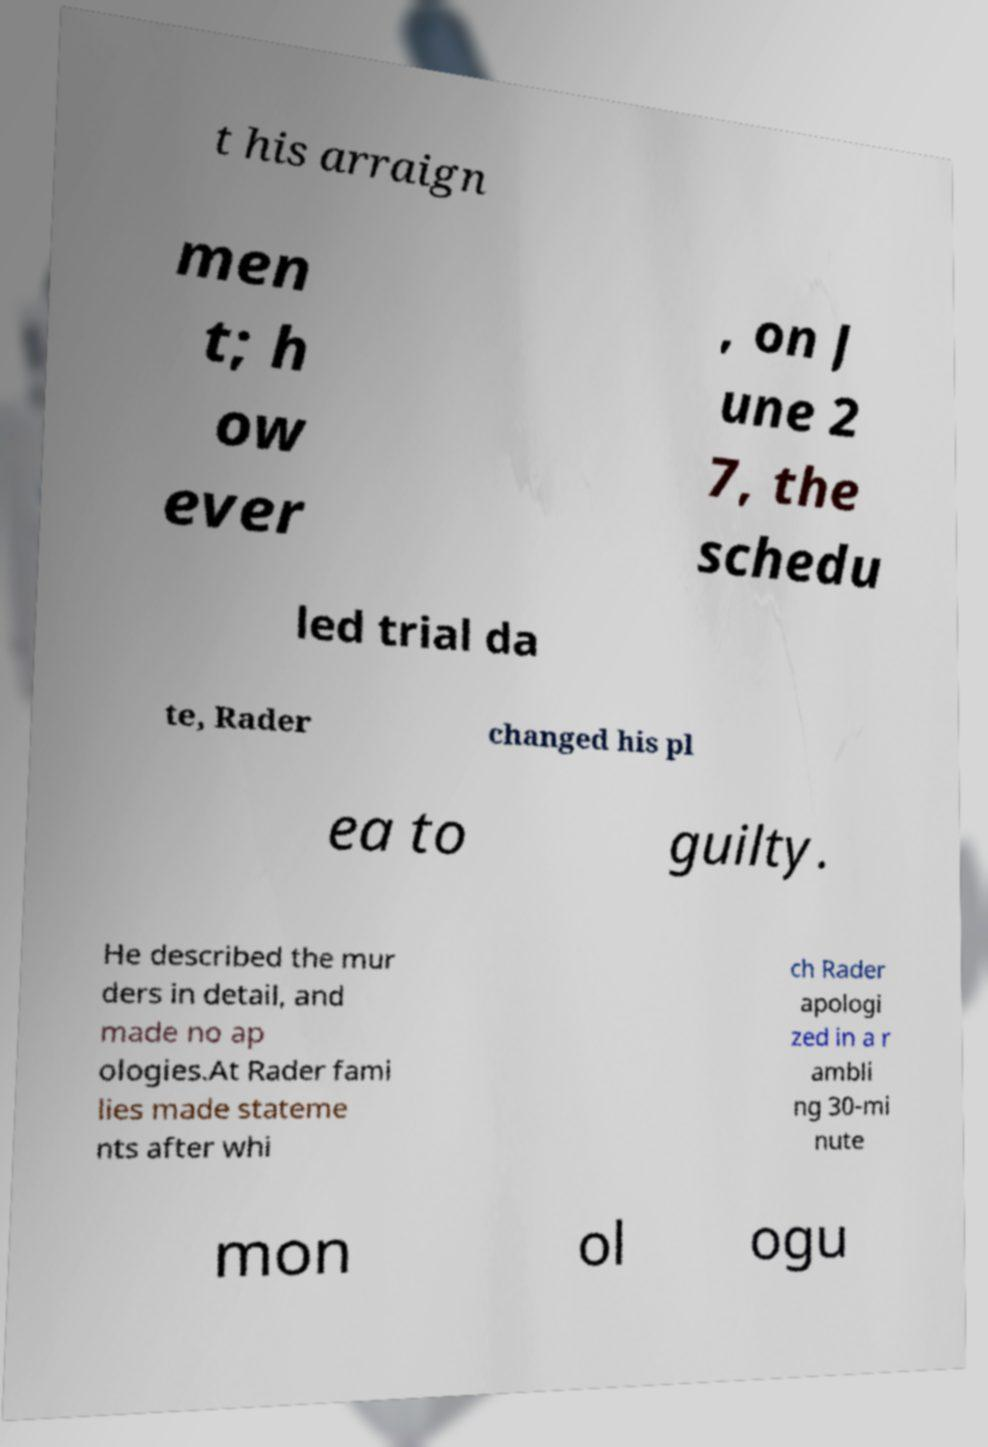Please identify and transcribe the text found in this image. t his arraign men t; h ow ever , on J une 2 7, the schedu led trial da te, Rader changed his pl ea to guilty. He described the mur ders in detail, and made no ap ologies.At Rader fami lies made stateme nts after whi ch Rader apologi zed in a r ambli ng 30-mi nute mon ol ogu 